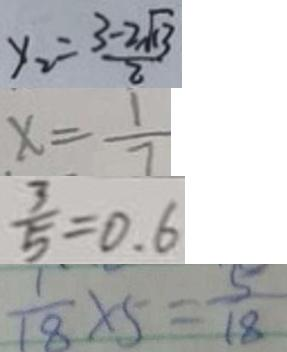<formula> <loc_0><loc_0><loc_500><loc_500>y _ { 2 } = \frac { 3 - 2 \sqrt { 1 3 } } { 2 } 
 x = \frac { 1 } { 7 } 
 \frac { 3 } { 5 } = 0 . 6 
 \frac { 1 } { 1 8 } \times 5 = \frac { 5 } { 1 8 }</formula> 